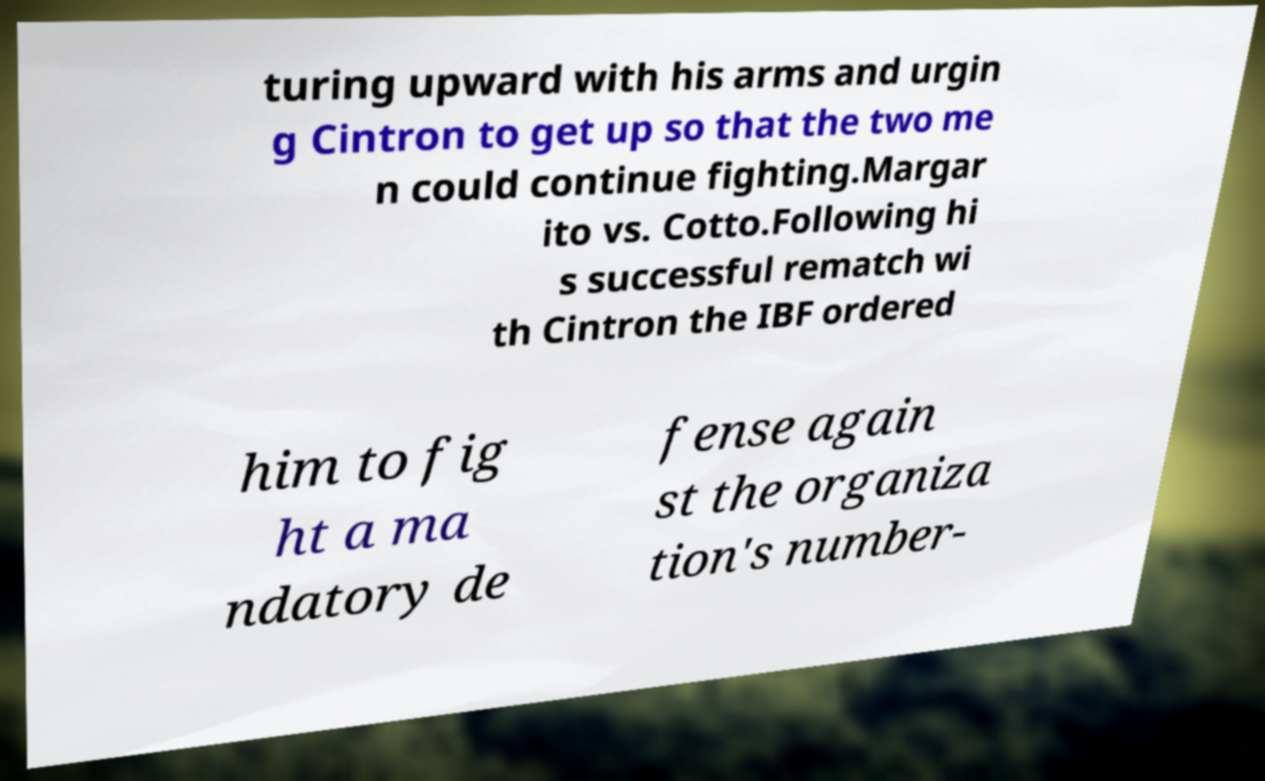Could you assist in decoding the text presented in this image and type it out clearly? turing upward with his arms and urgin g Cintron to get up so that the two me n could continue fighting.Margar ito vs. Cotto.Following hi s successful rematch wi th Cintron the IBF ordered him to fig ht a ma ndatory de fense again st the organiza tion's number- 